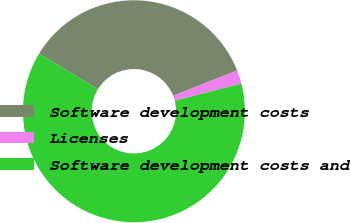Convert chart to OTSL. <chart><loc_0><loc_0><loc_500><loc_500><pie_chart><fcel>Software development costs<fcel>Licenses<fcel>Software development costs and<nl><fcel>35.32%<fcel>1.98%<fcel>62.7%<nl></chart> 